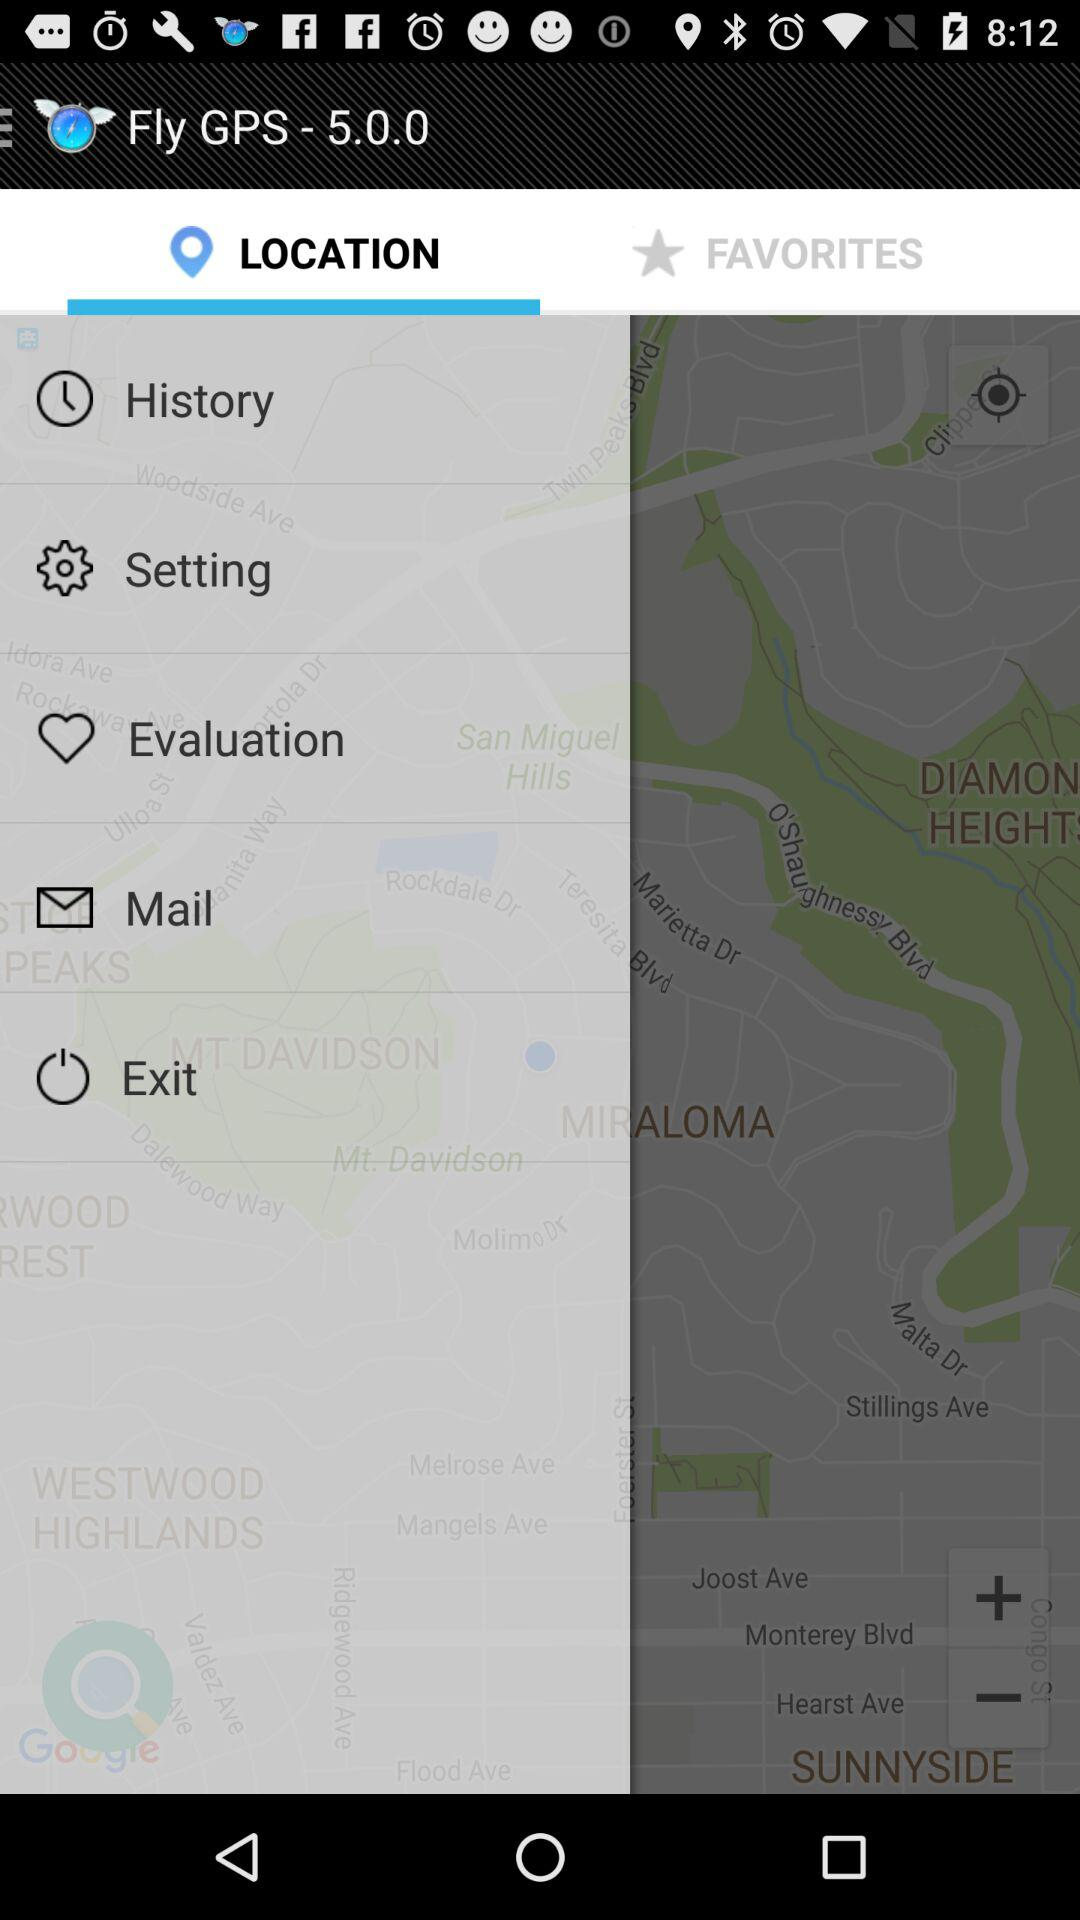What is the version of "Fly GPS"? The version of "Fly GPS" is 5.0.0. 